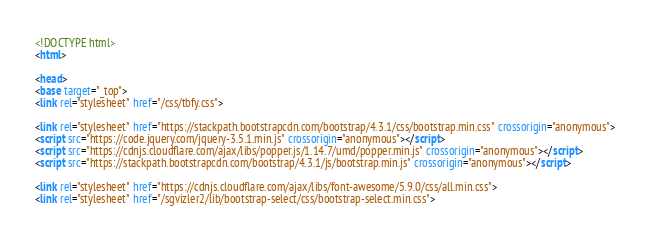<code> <loc_0><loc_0><loc_500><loc_500><_HTML_><!DOCTYPE html>
<html>

<head>
<base target="_top">
<link rel="stylesheet" href="/css/tbfy.css">

<link rel="stylesheet" href="https://stackpath.bootstrapcdn.com/bootstrap/4.3.1/css/bootstrap.min.css" crossorigin="anonymous">
<script src="https://code.jquery.com/jquery-3.5.1.min.js" crossorigin="anonymous"></script>
<script src="https://cdnjs.cloudflare.com/ajax/libs/popper.js/1.14.7/umd/popper.min.js" crossorigin="anonymous"></script>
<script src="https://stackpath.bootstrapcdn.com/bootstrap/4.3.1/js/bootstrap.min.js" crossorigin="anonymous"></script>

<link rel="stylesheet" href="https://cdnjs.cloudflare.com/ajax/libs/font-awesome/5.9.0/css/all.min.css">
<link rel="stylesheet" href="/sgvizler2/lib/bootstrap-select/css/bootstrap-select.min.css"></code> 